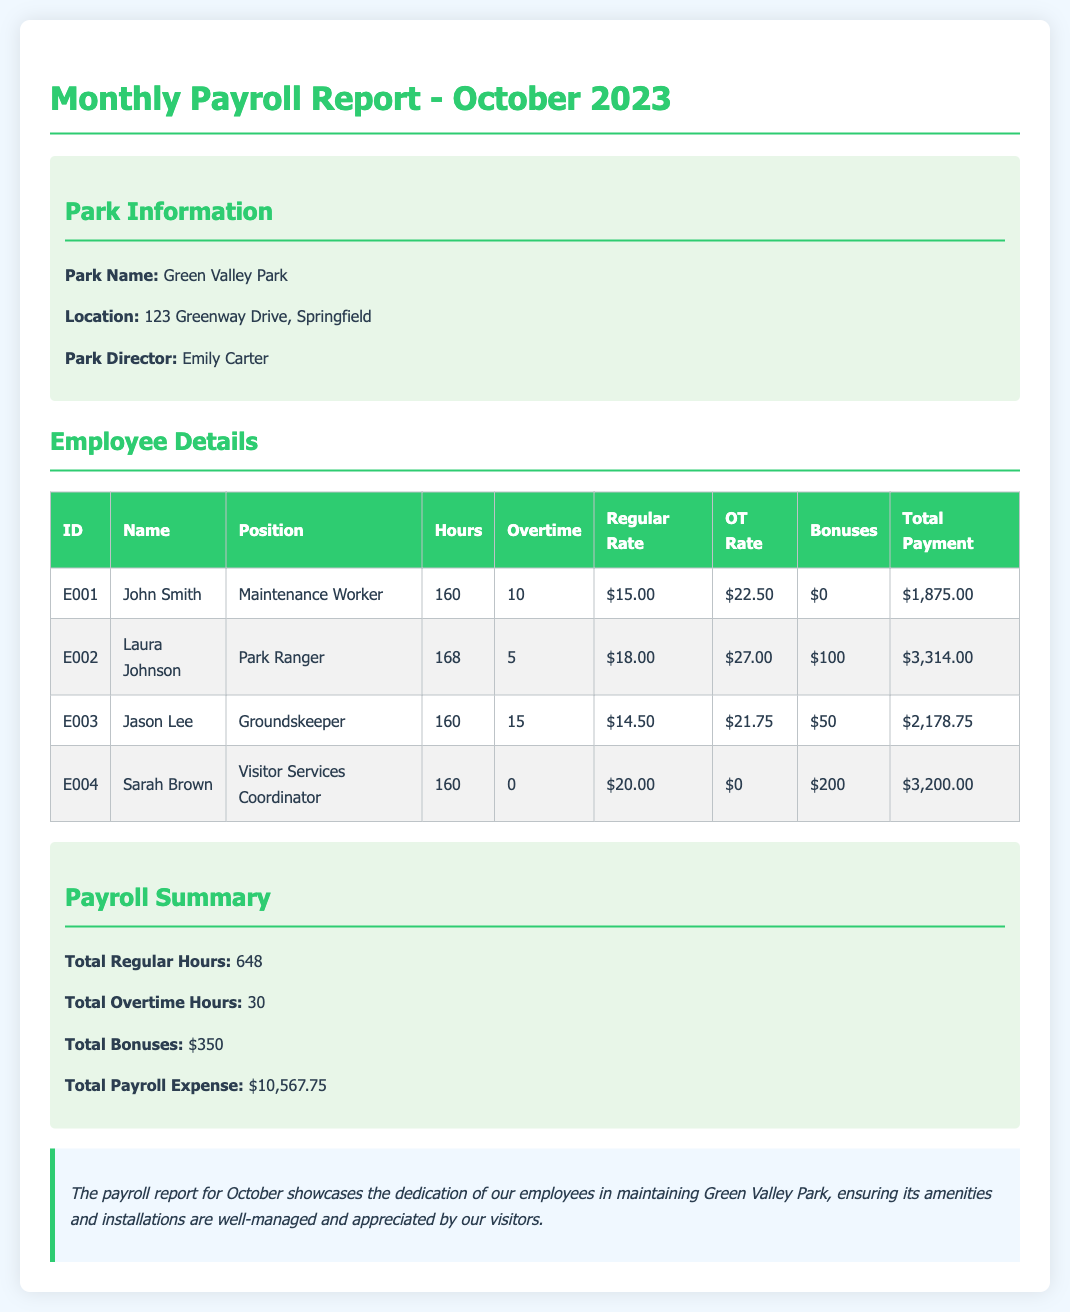What is the total payroll expense? Total payroll expense is calculated from the total payments made to all employees, which is $10,567.75.
Answer: $10,567.75 Who is the Park Director? The Park Director is named in the document, which is Emily Carter.
Answer: Emily Carter How many employees received bonuses? The document lists bonuses for employees and indicates two employees received bonuses: Laura Johnson and Sarah Brown.
Answer: 2 What is the overtime rate for Jason Lee? The overtime rate for Jason Lee is outlined as $21.75 in the document.
Answer: $21.75 What position holds the highest total payment? By reviewing total payments, Laura Johnson, as a Park Ranger, has the highest total payment of $3,314.00.
Answer: Park Ranger What is the total regular hours worked by all employees? The total regular hours worked is summed up in the summary section as 648 hours.
Answer: 648 Which employee worked overtime? Overtime is specified for employees and John Smith, Laura Johnson, and Jason Lee all worked overtime.
Answer: John Smith, Laura Johnson, Jason Lee What bonus did Sarah Brown receive? The document specifically states that Sarah Brown received a bonus of $200.
Answer: $200 